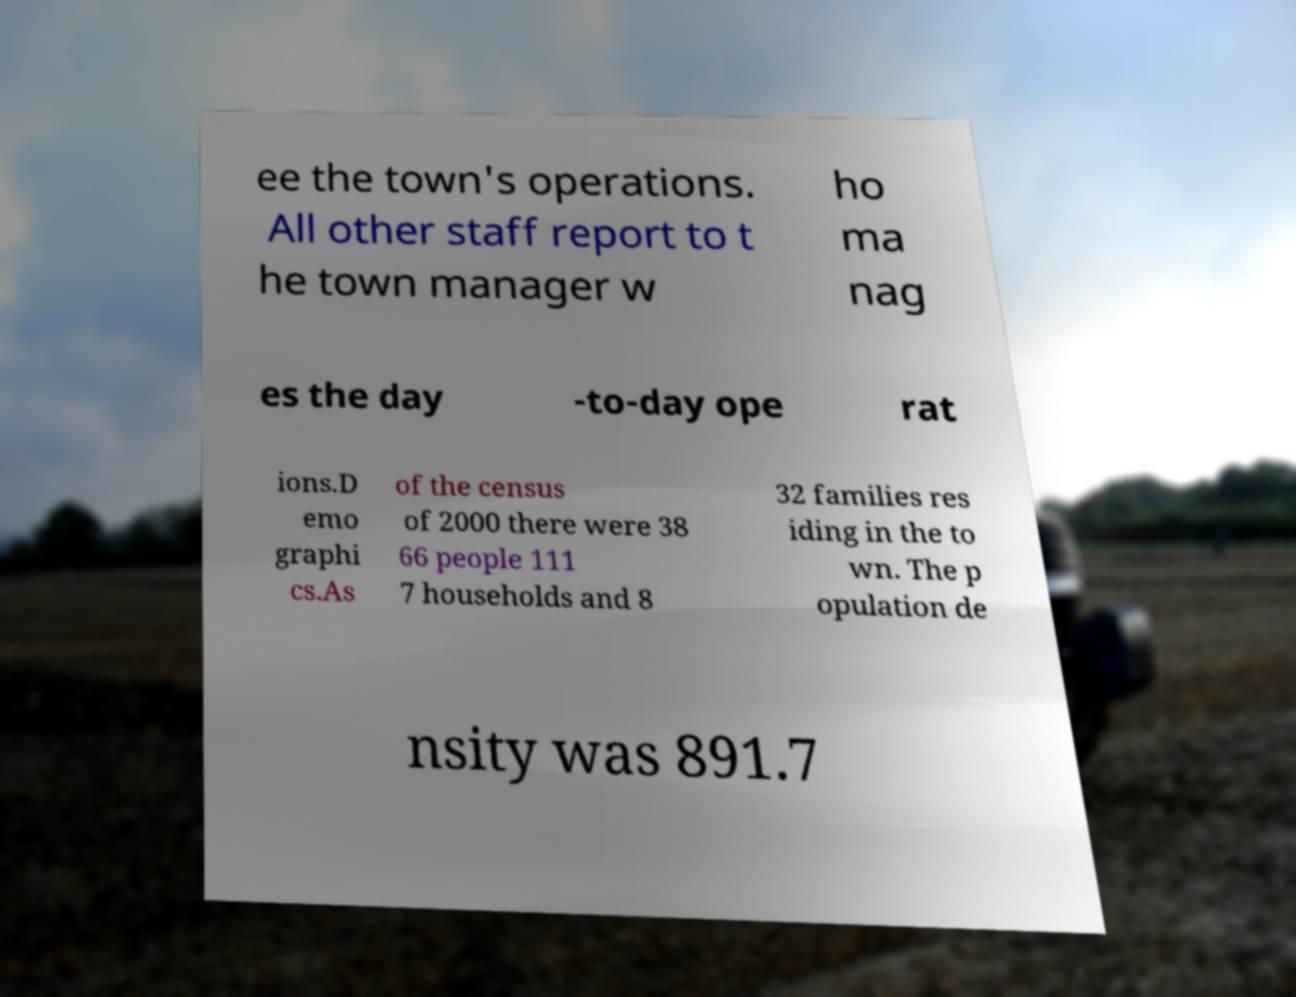What messages or text are displayed in this image? I need them in a readable, typed format. ee the town's operations. All other staff report to t he town manager w ho ma nag es the day -to-day ope rat ions.D emo graphi cs.As of the census of 2000 there were 38 66 people 111 7 households and 8 32 families res iding in the to wn. The p opulation de nsity was 891.7 